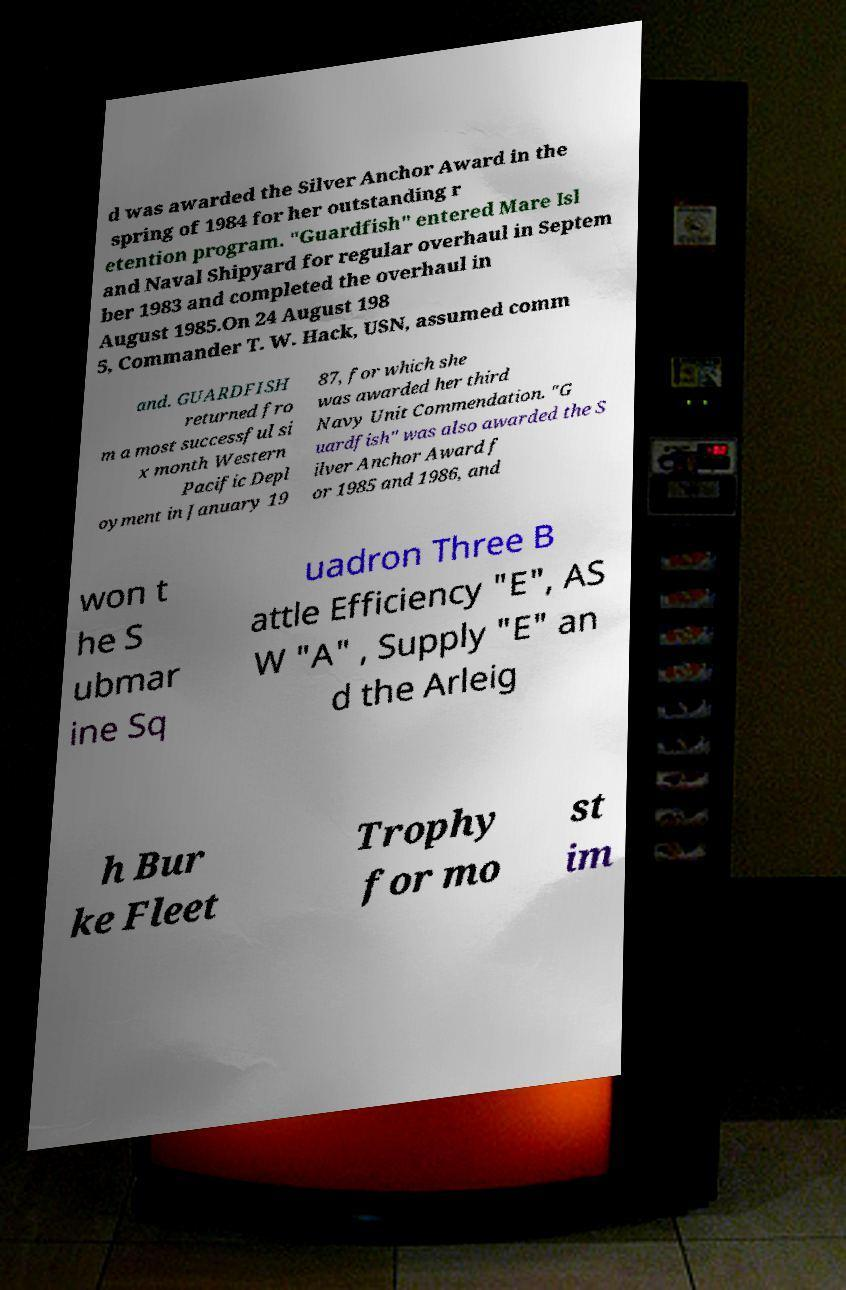For documentation purposes, I need the text within this image transcribed. Could you provide that? d was awarded the Silver Anchor Award in the spring of 1984 for her outstanding r etention program. "Guardfish" entered Mare Isl and Naval Shipyard for regular overhaul in Septem ber 1983 and completed the overhaul in August 1985.On 24 August 198 5, Commander T. W. Hack, USN, assumed comm and. GUARDFISH returned fro m a most successful si x month Western Pacific Depl oyment in January 19 87, for which she was awarded her third Navy Unit Commendation. "G uardfish" was also awarded the S ilver Anchor Award f or 1985 and 1986, and won t he S ubmar ine Sq uadron Three B attle Efficiency "E", AS W "A" , Supply "E" an d the Arleig h Bur ke Fleet Trophy for mo st im 